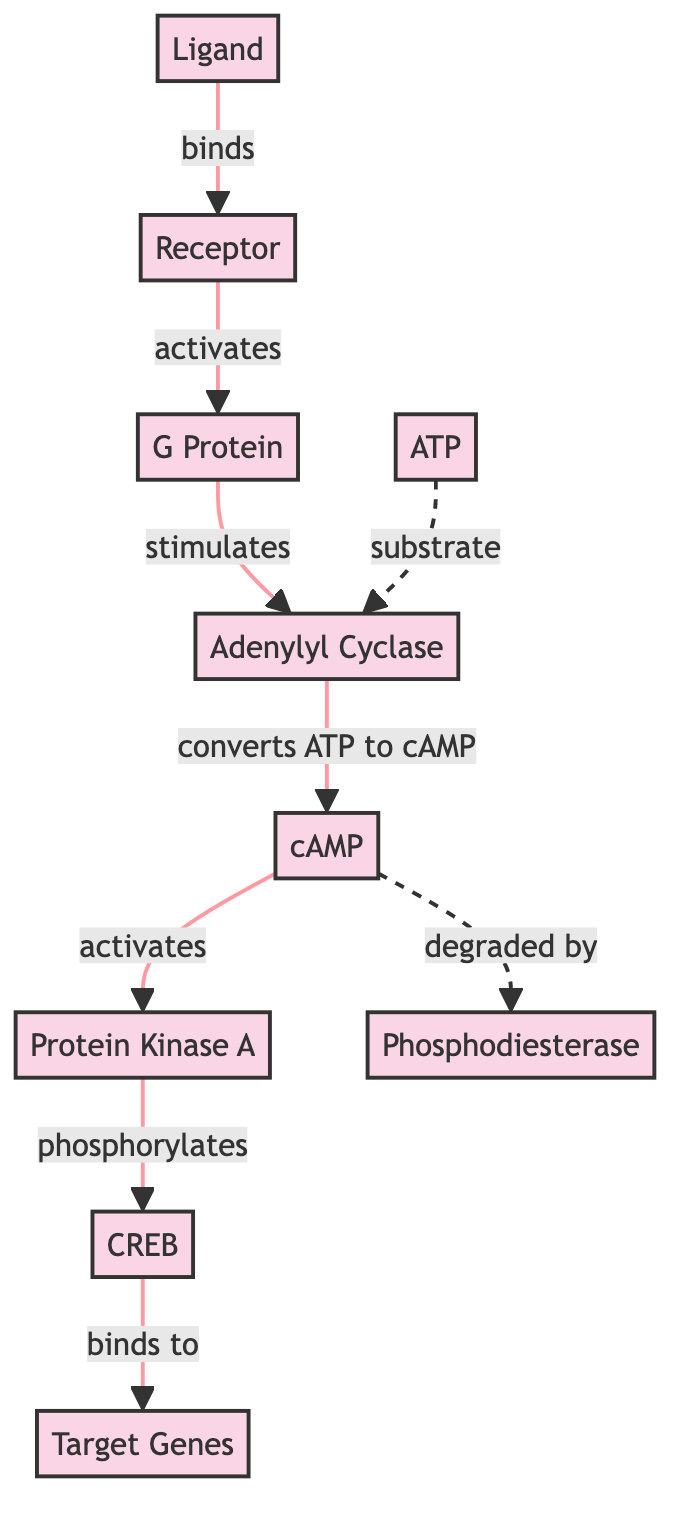What molecule binds to the receptor? The diagram indicates that the ligand is the molecule that specifically binds to the receptor, as shown by the arrow labeled "binds" connecting Ligand (1) to Receptor (2).
Answer: Ligand What is the function of adenylyl cyclase? The diagram shows that adenylyl cyclase stimulates the conversion of ATP to cAMP, which is indicated by the arrow labeled "converts ATP to cAMP" linking Adenylyl Cyclase (4) to cAMP (5).
Answer: Converts ATP to cAMP How many nodes represent biochemical molecules in this diagram? In the diagram, there are 10 nodes representing key biochemical molecules, as listed: Ligand, Receptor, G Protein, Adenylyl Cyclase, cAMP, Protein Kinase A, Phosphodiesterase, ATP, CREB, and Target Genes.
Answer: 10 Which molecule is activated by cAMP? The diagram shows that Protein Kinase A is activated by cAMP, indicated by the arrow labeled "activates" going from cAMP (5) to Protein Kinase A (6).
Answer: Protein Kinase A What role does phosphodiesterase play in relation to cAMP? The diagram indicates that phosphodiesterase degrades cAMP, as shown by the dashed arrow labeled "degraded by" that links cAMP (5) to Phosphodiesterase (7).
Answer: Degraded What is the relationship between CREB and target genes? The diagram demonstrates that CREB binds to target genes, indicated by the arrow labeled "binds to" connecting CREB (9) to Target Genes (10).
Answer: Binds to What initiates the activation of G Protein? The diagram shows that the receptor activates the G Protein, as indicated by the arrow labeled "activates" connecting Receptor (2) to G Protein (3).
Answer: Receptor Which molecule acts as a substrate for adenylyl cyclase? The diagram specifies that ATP acts as a substrate for adenylyl cyclase, which is shown by the dashed arrow linking ATP (8) to Adenylyl Cyclase (4) as "substrate."
Answer: ATP 